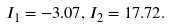Convert formula to latex. <formula><loc_0><loc_0><loc_500><loc_500>I _ { 1 } = - 3 . 0 7 , I _ { 2 } = 1 7 . 7 2 .</formula> 